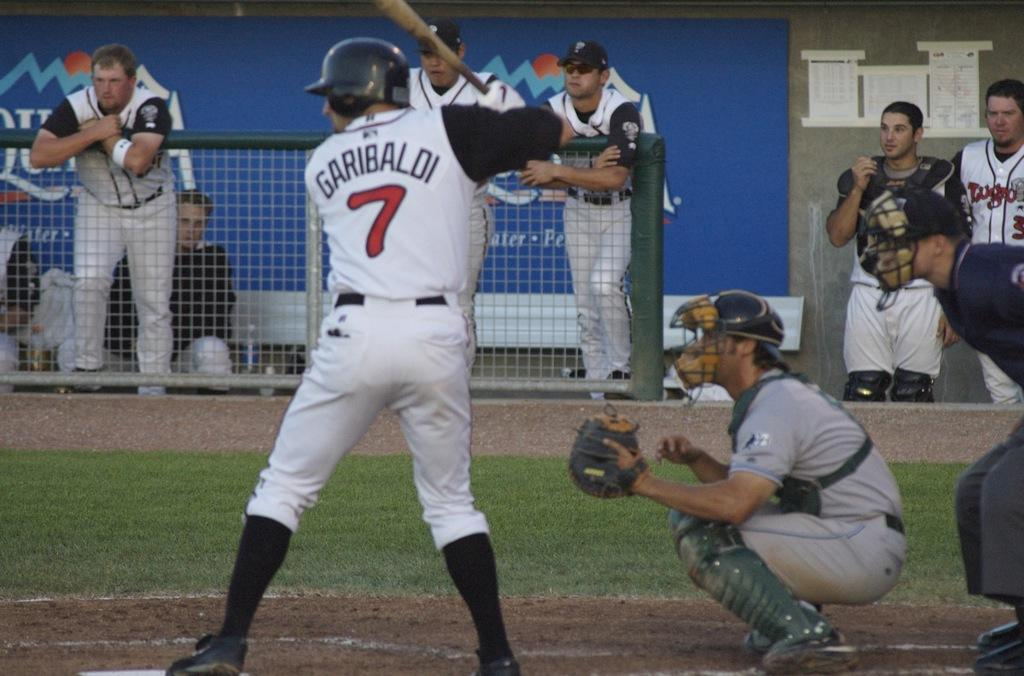<image>
Write a terse but informative summary of the picture. a player with the number 7 on his baseball jersey 